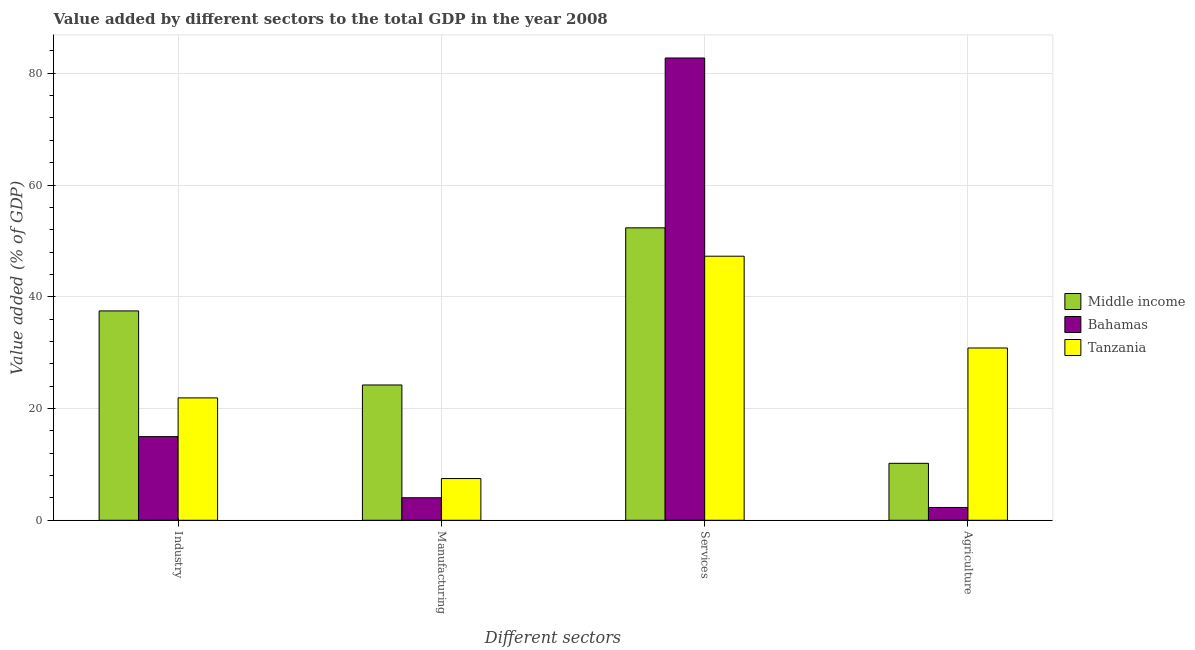Are the number of bars per tick equal to the number of legend labels?
Offer a terse response. Yes. Are the number of bars on each tick of the X-axis equal?
Provide a succinct answer. Yes. How many bars are there on the 4th tick from the left?
Keep it short and to the point. 3. What is the label of the 3rd group of bars from the left?
Make the answer very short. Services. What is the value added by manufacturing sector in Middle income?
Make the answer very short. 24.21. Across all countries, what is the maximum value added by services sector?
Provide a succinct answer. 82.74. Across all countries, what is the minimum value added by services sector?
Keep it short and to the point. 47.26. In which country was the value added by services sector maximum?
Your answer should be compact. Bahamas. In which country was the value added by services sector minimum?
Offer a terse response. Tanzania. What is the total value added by industrial sector in the graph?
Your answer should be very brief. 74.34. What is the difference between the value added by services sector in Bahamas and that in Middle income?
Your answer should be very brief. 30.4. What is the difference between the value added by manufacturing sector in Middle income and the value added by industrial sector in Bahamas?
Your response must be concise. 9.25. What is the average value added by agricultural sector per country?
Ensure brevity in your answer.  14.44. What is the difference between the value added by services sector and value added by manufacturing sector in Bahamas?
Give a very brief answer. 78.71. In how many countries, is the value added by manufacturing sector greater than 52 %?
Offer a terse response. 0. What is the ratio of the value added by services sector in Bahamas to that in Tanzania?
Your answer should be compact. 1.75. Is the difference between the value added by industrial sector in Middle income and Bahamas greater than the difference between the value added by services sector in Middle income and Bahamas?
Offer a very short reply. Yes. What is the difference between the highest and the second highest value added by manufacturing sector?
Ensure brevity in your answer.  16.75. What is the difference between the highest and the lowest value added by manufacturing sector?
Keep it short and to the point. 20.18. In how many countries, is the value added by industrial sector greater than the average value added by industrial sector taken over all countries?
Provide a short and direct response. 1. Is the sum of the value added by manufacturing sector in Bahamas and Middle income greater than the maximum value added by agricultural sector across all countries?
Make the answer very short. No. Is it the case that in every country, the sum of the value added by services sector and value added by manufacturing sector is greater than the sum of value added by agricultural sector and value added by industrial sector?
Your response must be concise. No. What does the 3rd bar from the left in Industry represents?
Offer a very short reply. Tanzania. What does the 3rd bar from the right in Industry represents?
Provide a short and direct response. Middle income. Is it the case that in every country, the sum of the value added by industrial sector and value added by manufacturing sector is greater than the value added by services sector?
Your answer should be compact. No. How many countries are there in the graph?
Your answer should be very brief. 3. Does the graph contain any zero values?
Your answer should be compact. No. Where does the legend appear in the graph?
Keep it short and to the point. Center right. How are the legend labels stacked?
Your answer should be compact. Vertical. What is the title of the graph?
Offer a terse response. Value added by different sectors to the total GDP in the year 2008. Does "Paraguay" appear as one of the legend labels in the graph?
Give a very brief answer. No. What is the label or title of the X-axis?
Ensure brevity in your answer.  Different sectors. What is the label or title of the Y-axis?
Your answer should be very brief. Value added (% of GDP). What is the Value added (% of GDP) of Middle income in Industry?
Make the answer very short. 37.47. What is the Value added (% of GDP) in Bahamas in Industry?
Give a very brief answer. 14.97. What is the Value added (% of GDP) in Tanzania in Industry?
Offer a terse response. 21.9. What is the Value added (% of GDP) in Middle income in Manufacturing?
Offer a very short reply. 24.21. What is the Value added (% of GDP) in Bahamas in Manufacturing?
Provide a succinct answer. 4.03. What is the Value added (% of GDP) of Tanzania in Manufacturing?
Your answer should be compact. 7.46. What is the Value added (% of GDP) of Middle income in Services?
Keep it short and to the point. 52.34. What is the Value added (% of GDP) of Bahamas in Services?
Ensure brevity in your answer.  82.74. What is the Value added (% of GDP) of Tanzania in Services?
Ensure brevity in your answer.  47.26. What is the Value added (% of GDP) in Middle income in Agriculture?
Offer a terse response. 10.19. What is the Value added (% of GDP) of Bahamas in Agriculture?
Your answer should be very brief. 2.29. What is the Value added (% of GDP) of Tanzania in Agriculture?
Provide a short and direct response. 30.83. Across all Different sectors, what is the maximum Value added (% of GDP) in Middle income?
Your response must be concise. 52.34. Across all Different sectors, what is the maximum Value added (% of GDP) in Bahamas?
Keep it short and to the point. 82.74. Across all Different sectors, what is the maximum Value added (% of GDP) in Tanzania?
Offer a very short reply. 47.26. Across all Different sectors, what is the minimum Value added (% of GDP) in Middle income?
Make the answer very short. 10.19. Across all Different sectors, what is the minimum Value added (% of GDP) of Bahamas?
Ensure brevity in your answer.  2.29. Across all Different sectors, what is the minimum Value added (% of GDP) in Tanzania?
Make the answer very short. 7.46. What is the total Value added (% of GDP) in Middle income in the graph?
Provide a short and direct response. 124.21. What is the total Value added (% of GDP) in Bahamas in the graph?
Your answer should be compact. 104.03. What is the total Value added (% of GDP) of Tanzania in the graph?
Provide a short and direct response. 107.46. What is the difference between the Value added (% of GDP) of Middle income in Industry and that in Manufacturing?
Your answer should be compact. 13.25. What is the difference between the Value added (% of GDP) of Bahamas in Industry and that in Manufacturing?
Offer a terse response. 10.94. What is the difference between the Value added (% of GDP) of Tanzania in Industry and that in Manufacturing?
Provide a short and direct response. 14.44. What is the difference between the Value added (% of GDP) in Middle income in Industry and that in Services?
Offer a very short reply. -14.87. What is the difference between the Value added (% of GDP) in Bahamas in Industry and that in Services?
Offer a very short reply. -67.77. What is the difference between the Value added (% of GDP) in Tanzania in Industry and that in Services?
Offer a terse response. -25.36. What is the difference between the Value added (% of GDP) in Middle income in Industry and that in Agriculture?
Give a very brief answer. 27.28. What is the difference between the Value added (% of GDP) in Bahamas in Industry and that in Agriculture?
Offer a terse response. 12.68. What is the difference between the Value added (% of GDP) of Tanzania in Industry and that in Agriculture?
Provide a succinct answer. -8.93. What is the difference between the Value added (% of GDP) in Middle income in Manufacturing and that in Services?
Provide a short and direct response. -28.12. What is the difference between the Value added (% of GDP) of Bahamas in Manufacturing and that in Services?
Your response must be concise. -78.71. What is the difference between the Value added (% of GDP) of Tanzania in Manufacturing and that in Services?
Provide a short and direct response. -39.8. What is the difference between the Value added (% of GDP) of Middle income in Manufacturing and that in Agriculture?
Your answer should be compact. 14.02. What is the difference between the Value added (% of GDP) of Bahamas in Manufacturing and that in Agriculture?
Ensure brevity in your answer.  1.74. What is the difference between the Value added (% of GDP) of Tanzania in Manufacturing and that in Agriculture?
Your answer should be compact. -23.37. What is the difference between the Value added (% of GDP) in Middle income in Services and that in Agriculture?
Keep it short and to the point. 42.15. What is the difference between the Value added (% of GDP) of Bahamas in Services and that in Agriculture?
Ensure brevity in your answer.  80.44. What is the difference between the Value added (% of GDP) of Tanzania in Services and that in Agriculture?
Your answer should be very brief. 16.43. What is the difference between the Value added (% of GDP) of Middle income in Industry and the Value added (% of GDP) of Bahamas in Manufacturing?
Keep it short and to the point. 33.44. What is the difference between the Value added (% of GDP) of Middle income in Industry and the Value added (% of GDP) of Tanzania in Manufacturing?
Your answer should be very brief. 30. What is the difference between the Value added (% of GDP) in Bahamas in Industry and the Value added (% of GDP) in Tanzania in Manufacturing?
Provide a short and direct response. 7.5. What is the difference between the Value added (% of GDP) of Middle income in Industry and the Value added (% of GDP) of Bahamas in Services?
Provide a short and direct response. -45.27. What is the difference between the Value added (% of GDP) in Middle income in Industry and the Value added (% of GDP) in Tanzania in Services?
Provide a short and direct response. -9.8. What is the difference between the Value added (% of GDP) in Bahamas in Industry and the Value added (% of GDP) in Tanzania in Services?
Keep it short and to the point. -32.29. What is the difference between the Value added (% of GDP) in Middle income in Industry and the Value added (% of GDP) in Bahamas in Agriculture?
Make the answer very short. 35.18. What is the difference between the Value added (% of GDP) in Middle income in Industry and the Value added (% of GDP) in Tanzania in Agriculture?
Offer a very short reply. 6.64. What is the difference between the Value added (% of GDP) in Bahamas in Industry and the Value added (% of GDP) in Tanzania in Agriculture?
Your answer should be very brief. -15.86. What is the difference between the Value added (% of GDP) of Middle income in Manufacturing and the Value added (% of GDP) of Bahamas in Services?
Give a very brief answer. -58.52. What is the difference between the Value added (% of GDP) of Middle income in Manufacturing and the Value added (% of GDP) of Tanzania in Services?
Ensure brevity in your answer.  -23.05. What is the difference between the Value added (% of GDP) of Bahamas in Manufacturing and the Value added (% of GDP) of Tanzania in Services?
Your response must be concise. -43.23. What is the difference between the Value added (% of GDP) of Middle income in Manufacturing and the Value added (% of GDP) of Bahamas in Agriculture?
Your answer should be compact. 21.92. What is the difference between the Value added (% of GDP) of Middle income in Manufacturing and the Value added (% of GDP) of Tanzania in Agriculture?
Give a very brief answer. -6.62. What is the difference between the Value added (% of GDP) in Bahamas in Manufacturing and the Value added (% of GDP) in Tanzania in Agriculture?
Your answer should be compact. -26.8. What is the difference between the Value added (% of GDP) in Middle income in Services and the Value added (% of GDP) in Bahamas in Agriculture?
Keep it short and to the point. 50.04. What is the difference between the Value added (% of GDP) in Middle income in Services and the Value added (% of GDP) in Tanzania in Agriculture?
Provide a succinct answer. 21.5. What is the difference between the Value added (% of GDP) of Bahamas in Services and the Value added (% of GDP) of Tanzania in Agriculture?
Ensure brevity in your answer.  51.9. What is the average Value added (% of GDP) in Middle income per Different sectors?
Keep it short and to the point. 31.05. What is the average Value added (% of GDP) in Bahamas per Different sectors?
Keep it short and to the point. 26.01. What is the average Value added (% of GDP) of Tanzania per Different sectors?
Your answer should be very brief. 26.87. What is the difference between the Value added (% of GDP) in Middle income and Value added (% of GDP) in Bahamas in Industry?
Offer a terse response. 22.5. What is the difference between the Value added (% of GDP) of Middle income and Value added (% of GDP) of Tanzania in Industry?
Make the answer very short. 15.57. What is the difference between the Value added (% of GDP) in Bahamas and Value added (% of GDP) in Tanzania in Industry?
Give a very brief answer. -6.93. What is the difference between the Value added (% of GDP) in Middle income and Value added (% of GDP) in Bahamas in Manufacturing?
Your response must be concise. 20.18. What is the difference between the Value added (% of GDP) of Middle income and Value added (% of GDP) of Tanzania in Manufacturing?
Offer a very short reply. 16.75. What is the difference between the Value added (% of GDP) of Bahamas and Value added (% of GDP) of Tanzania in Manufacturing?
Your answer should be compact. -3.43. What is the difference between the Value added (% of GDP) of Middle income and Value added (% of GDP) of Bahamas in Services?
Keep it short and to the point. -30.4. What is the difference between the Value added (% of GDP) of Middle income and Value added (% of GDP) of Tanzania in Services?
Provide a succinct answer. 5.07. What is the difference between the Value added (% of GDP) of Bahamas and Value added (% of GDP) of Tanzania in Services?
Your answer should be compact. 35.47. What is the difference between the Value added (% of GDP) of Middle income and Value added (% of GDP) of Bahamas in Agriculture?
Make the answer very short. 7.9. What is the difference between the Value added (% of GDP) of Middle income and Value added (% of GDP) of Tanzania in Agriculture?
Your response must be concise. -20.64. What is the difference between the Value added (% of GDP) of Bahamas and Value added (% of GDP) of Tanzania in Agriculture?
Keep it short and to the point. -28.54. What is the ratio of the Value added (% of GDP) of Middle income in Industry to that in Manufacturing?
Your answer should be compact. 1.55. What is the ratio of the Value added (% of GDP) in Bahamas in Industry to that in Manufacturing?
Offer a very short reply. 3.71. What is the ratio of the Value added (% of GDP) of Tanzania in Industry to that in Manufacturing?
Ensure brevity in your answer.  2.93. What is the ratio of the Value added (% of GDP) in Middle income in Industry to that in Services?
Offer a very short reply. 0.72. What is the ratio of the Value added (% of GDP) in Bahamas in Industry to that in Services?
Your answer should be very brief. 0.18. What is the ratio of the Value added (% of GDP) in Tanzania in Industry to that in Services?
Provide a short and direct response. 0.46. What is the ratio of the Value added (% of GDP) in Middle income in Industry to that in Agriculture?
Give a very brief answer. 3.68. What is the ratio of the Value added (% of GDP) in Bahamas in Industry to that in Agriculture?
Your response must be concise. 6.53. What is the ratio of the Value added (% of GDP) of Tanzania in Industry to that in Agriculture?
Ensure brevity in your answer.  0.71. What is the ratio of the Value added (% of GDP) in Middle income in Manufacturing to that in Services?
Ensure brevity in your answer.  0.46. What is the ratio of the Value added (% of GDP) in Bahamas in Manufacturing to that in Services?
Provide a short and direct response. 0.05. What is the ratio of the Value added (% of GDP) in Tanzania in Manufacturing to that in Services?
Give a very brief answer. 0.16. What is the ratio of the Value added (% of GDP) in Middle income in Manufacturing to that in Agriculture?
Provide a short and direct response. 2.38. What is the ratio of the Value added (% of GDP) of Bahamas in Manufacturing to that in Agriculture?
Offer a very short reply. 1.76. What is the ratio of the Value added (% of GDP) of Tanzania in Manufacturing to that in Agriculture?
Offer a terse response. 0.24. What is the ratio of the Value added (% of GDP) in Middle income in Services to that in Agriculture?
Keep it short and to the point. 5.14. What is the ratio of the Value added (% of GDP) in Bahamas in Services to that in Agriculture?
Provide a short and direct response. 36.08. What is the ratio of the Value added (% of GDP) of Tanzania in Services to that in Agriculture?
Ensure brevity in your answer.  1.53. What is the difference between the highest and the second highest Value added (% of GDP) of Middle income?
Offer a terse response. 14.87. What is the difference between the highest and the second highest Value added (% of GDP) in Bahamas?
Your answer should be compact. 67.77. What is the difference between the highest and the second highest Value added (% of GDP) of Tanzania?
Offer a terse response. 16.43. What is the difference between the highest and the lowest Value added (% of GDP) in Middle income?
Keep it short and to the point. 42.15. What is the difference between the highest and the lowest Value added (% of GDP) in Bahamas?
Offer a terse response. 80.44. What is the difference between the highest and the lowest Value added (% of GDP) of Tanzania?
Provide a succinct answer. 39.8. 